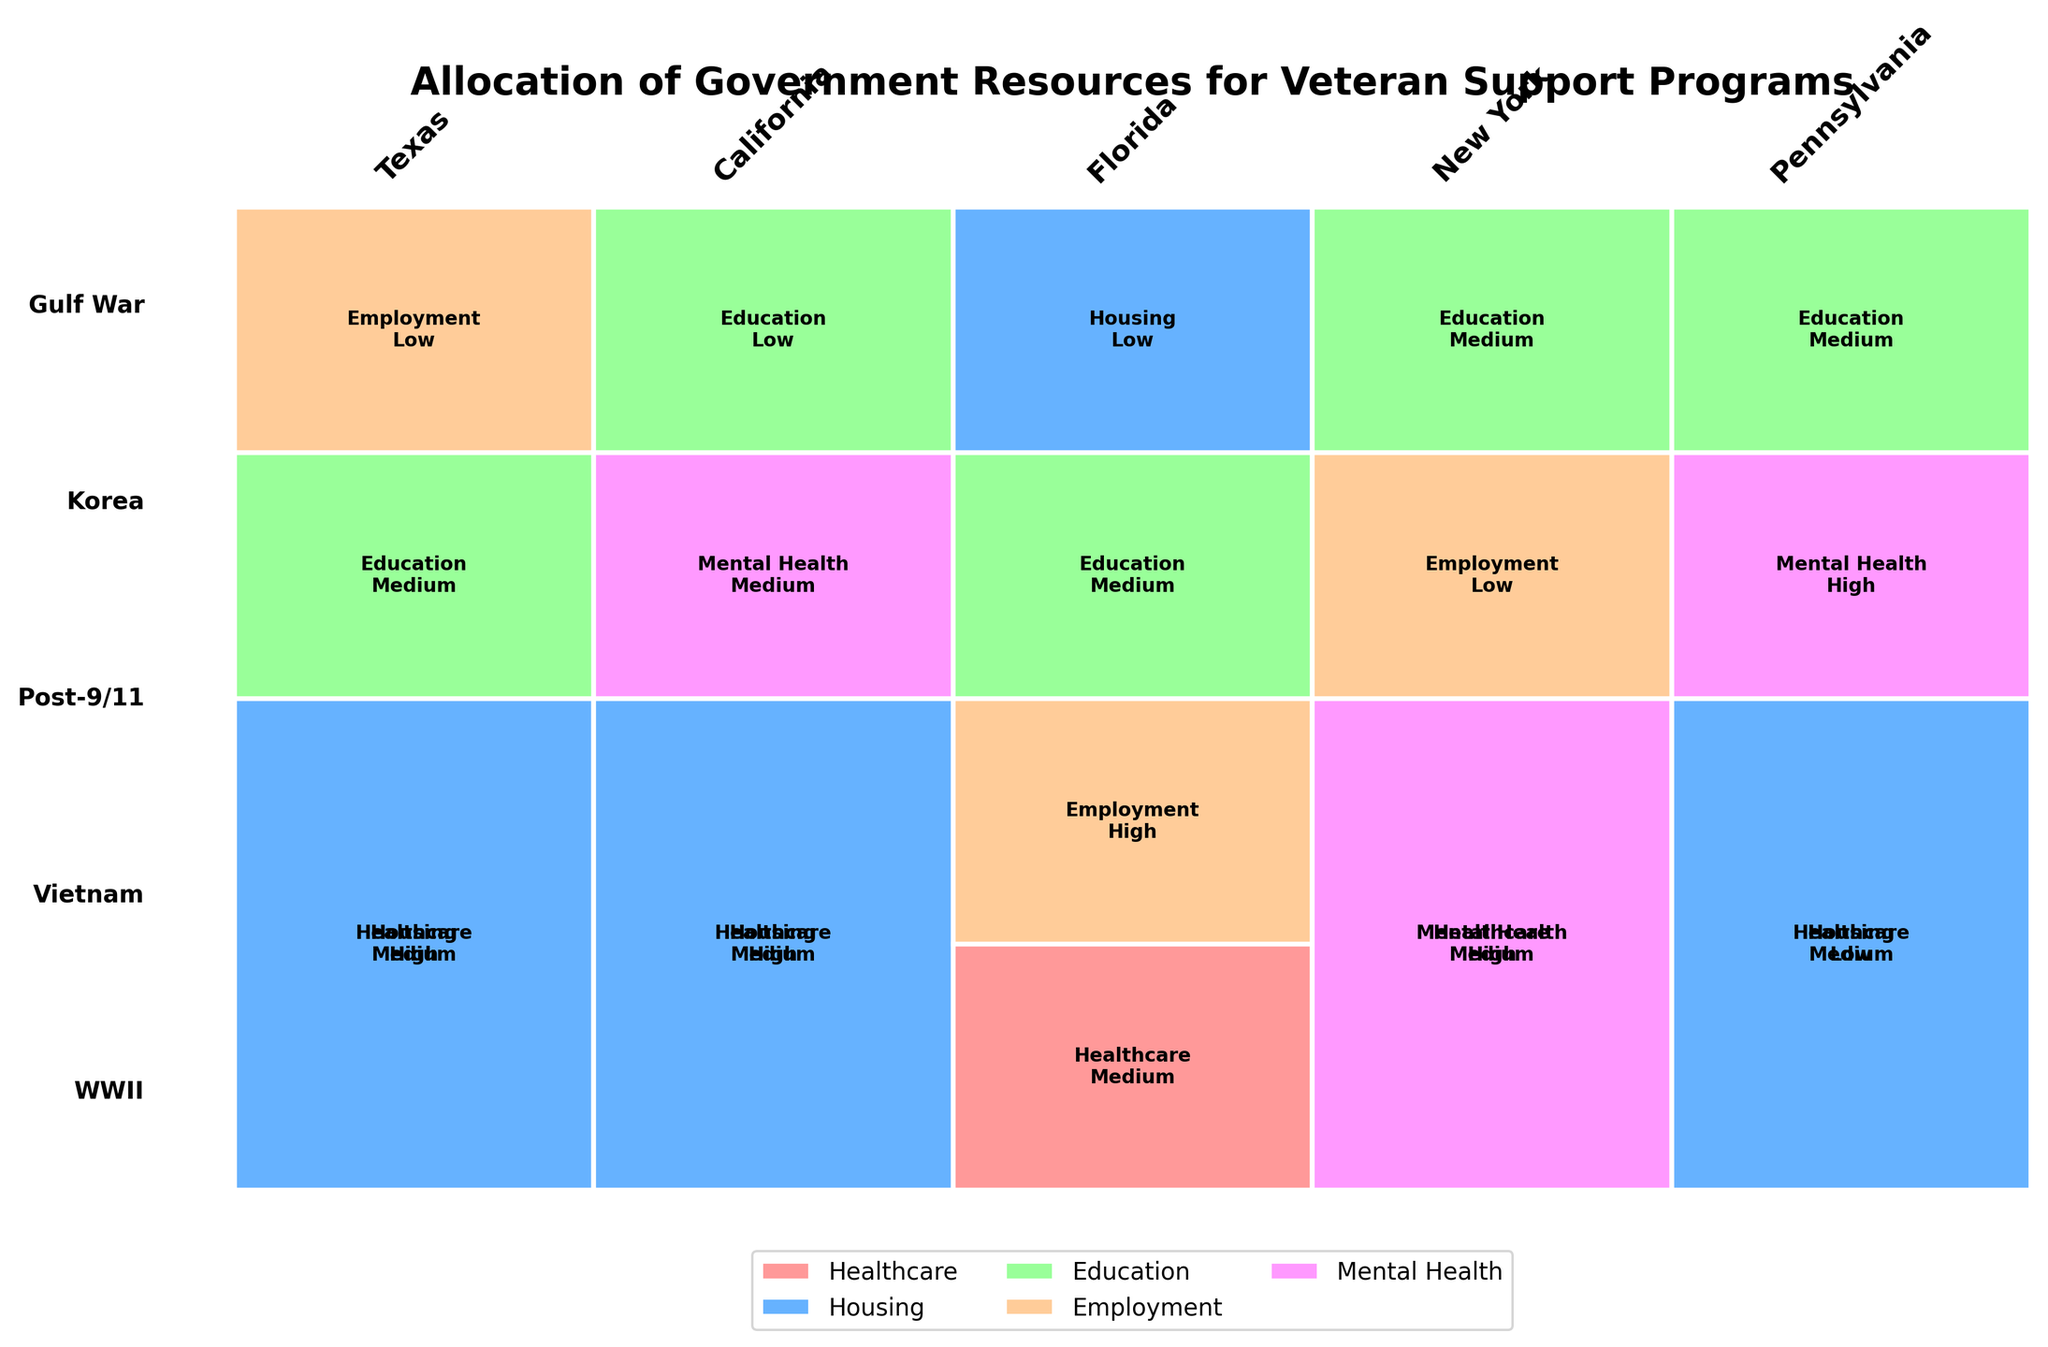Which state has the highest funding for WWII veterans' healthcare? In the figure, Texas, California, New York, and Pennsylvania have high funding for WWII veterans' healthcare. To determine which state has the highest, look for the largest rectangle labeled as "Healthcare" and "High" under the WWII era.
Answer: Multiple states have equal high funding for WWII veterans' healthcare What type of program is funded the most for Vietnam-era veterans in Florida? Observe the Vietnam era section for the state of Florida and identify which program type has the largest area. The program with high funding is Employment.
Answer: Employment Which era has the least allocation in California? Examine the height of each section within the California state area. The smallest section corresponds to the Korea era.
Answer: Korea How does the funding for Housing programs compare between Texas and Pennsylvania? Find the rectangles labeled "Housing" in both Texas and Pennsylvania sections. In Texas, there's medium funding, while in Pennsylvania, it's low funding for Housing programs.
Answer: Texas has higher Housing funding Which state has a medium level funding for Mental Health programs for WWII veterans? Look for the "WWII" era and then identify the programs labeled "Mental Health" with medium funding across all states. This information corresponds to New York.
Answer: New York What is the most common type of program funded across all states for WWII veterans? By inspecting the rectangles under "WWII" era across all states and noting the frequency of each program type, Healthcare appears most frequently.
Answer: Healthcare If you sum up the medium funding levels for Post-9/11 era across all states, how many instances do you get? Look under the Post-9/11 era in each state and count instances where funding levels are marked as medium. Florida has one medium funding for Education and Pennsylvania has one medium funding for Education. Summing these gives two instances.
Answer: Two Which program type has a presence in every state for any service era? Identify any program type that appears at least once in all states across any service era. Healthcare is evident in Texas, California, Florida, New York, and Pennsylvania.
Answer: Healthcare Compare the funding of Education programs in California and New York during the Post-9/11 era. Identify the Post-9/11 era in both California and New York, then look at the funding levels for Education. California does not have data for the Post-9/11 era, but New York has medium funding for Education programs.
Answer: New York has medium funding 